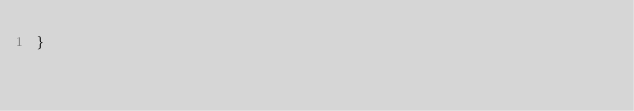<code> <loc_0><loc_0><loc_500><loc_500><_Haxe_>}
</code> 